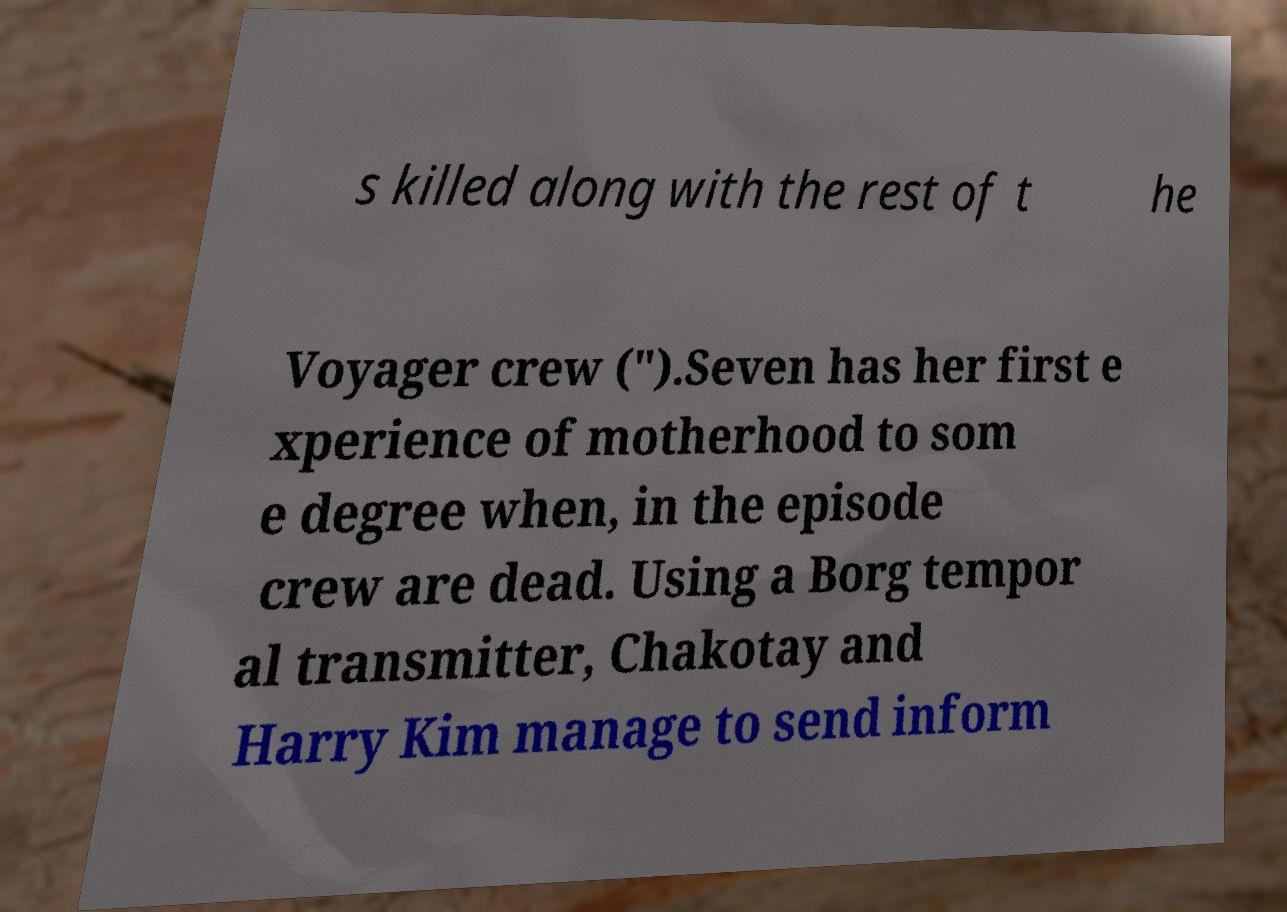Please identify and transcribe the text found in this image. s killed along with the rest of t he Voyager crew (").Seven has her first e xperience of motherhood to som e degree when, in the episode crew are dead. Using a Borg tempor al transmitter, Chakotay and Harry Kim manage to send inform 